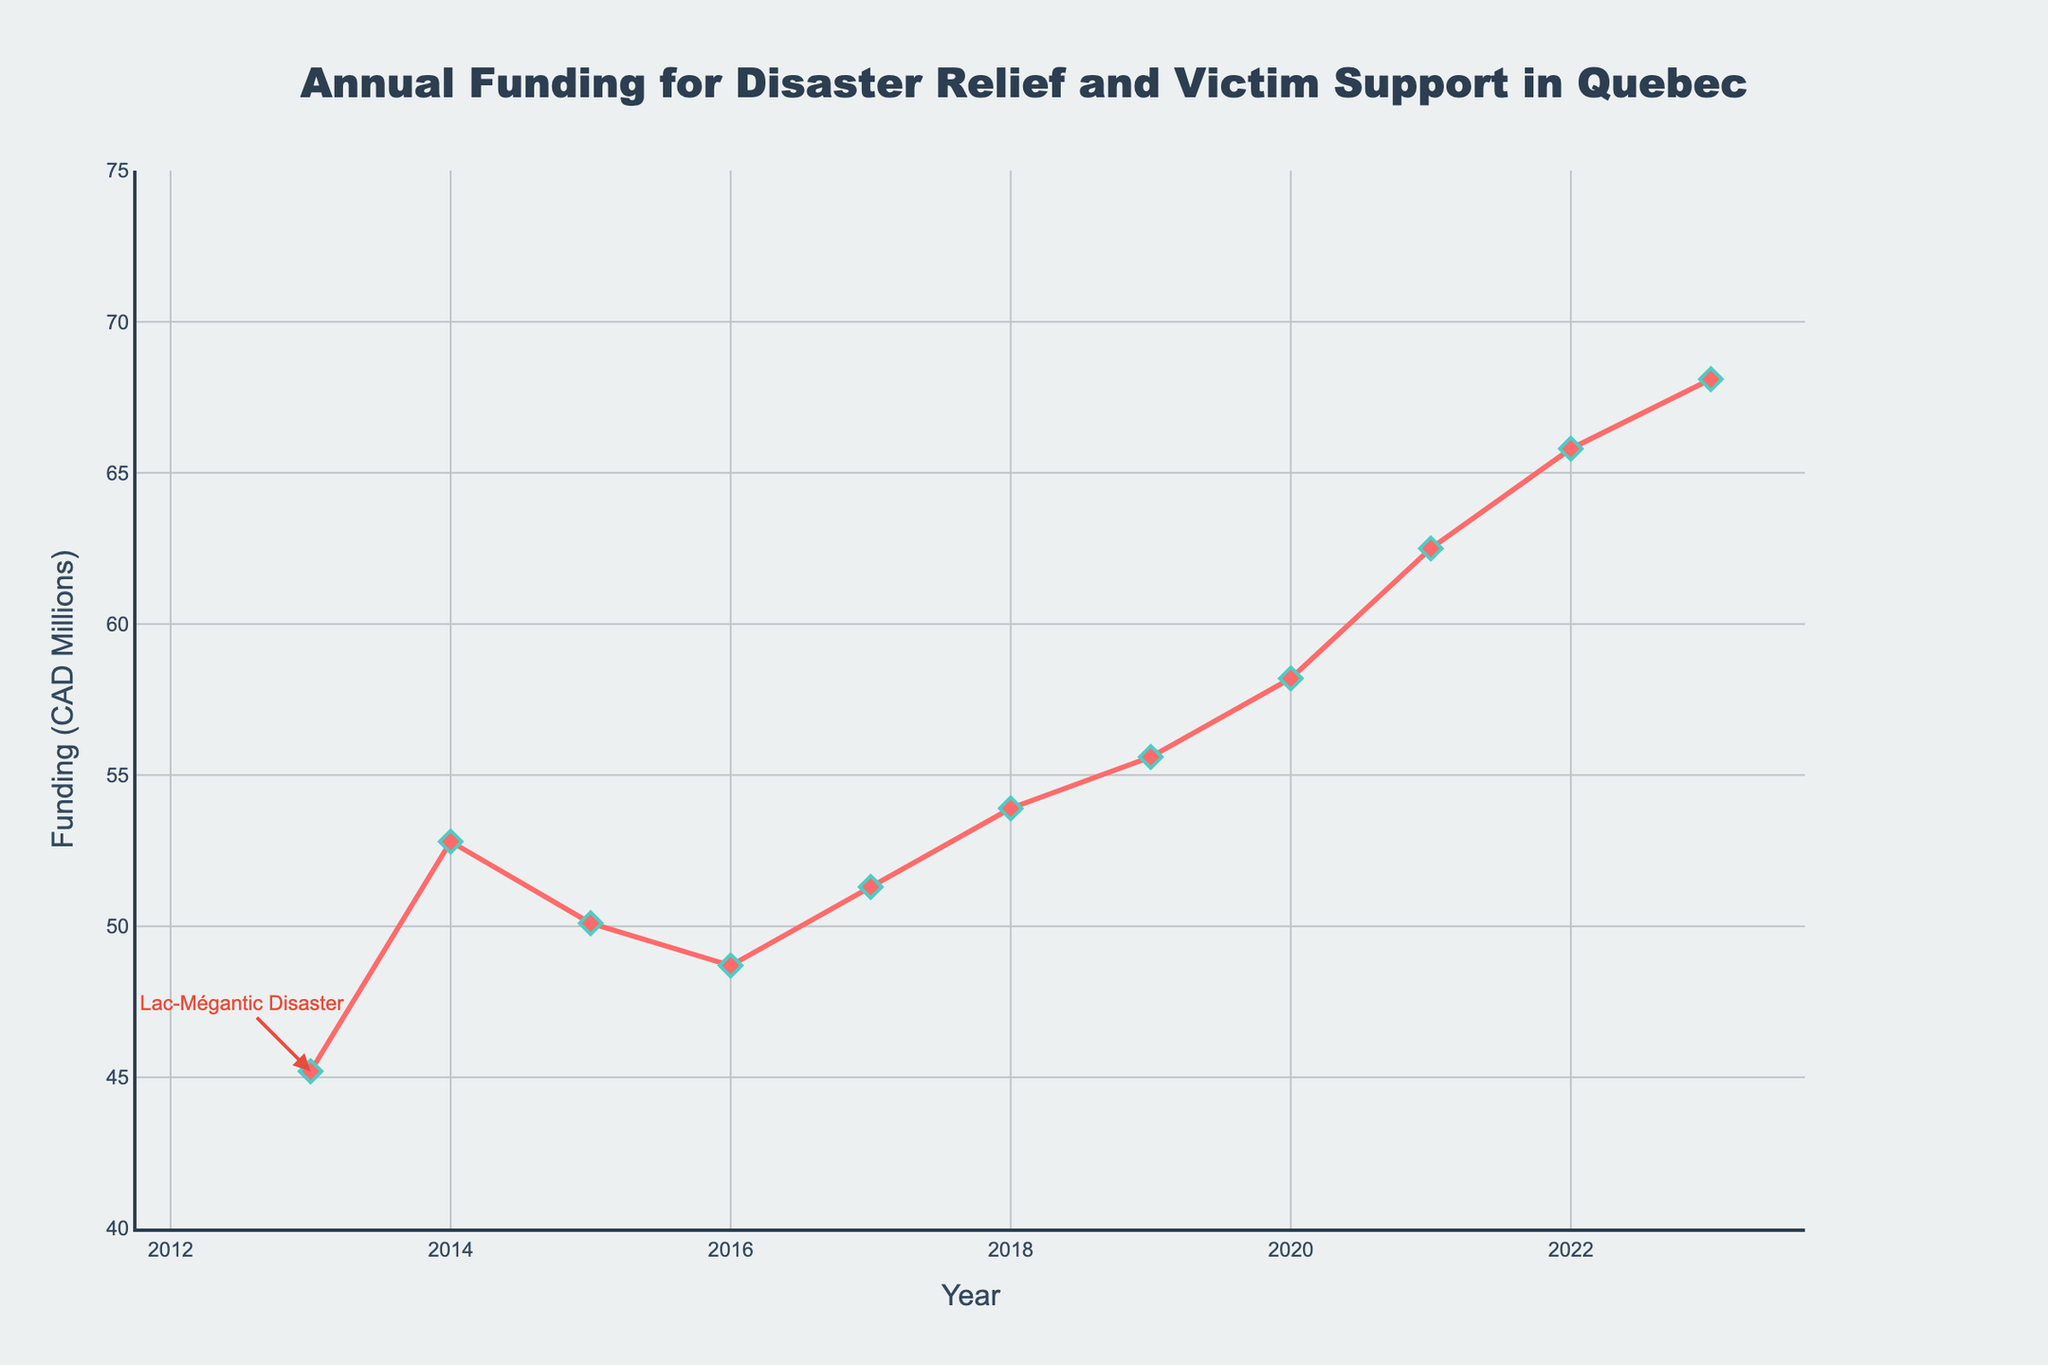What was the funding allocated in the year of the Lac-Mégantic disaster? The figure shows an annotation pointing to the year 2013 with a funding amount of 45.2 million CAD.
Answer: 45.2 million CAD How much did the funding increase from 2013 to 2014? According to the figure, the funding in 2013 was 45.2 million CAD and in 2014 it was 52.8 million CAD. The increase can be calculated as 52.8 - 45.2.
Answer: 7.6 million CAD Which year marked the highest funding allocation? The highest point on the line in the figure corresponds to the year 2023 with a value of 68.1 million CAD.
Answer: 2023 How much was the funding in 2018 compared to 2016? From the figure, the funding in 2016 was 48.7 million CAD and in 2018 it was 53.9 million CAD. To find the difference, we subtract 48.7 from 53.9.
Answer: 5.2 million CAD more What is the average annual funding from 2013 to 2023? First, sum up all annual funding values: 45.2 + 52.8 + 50.1 + 48.7 + 51.3 + 53.9 + 55.6 + 58.2 + 62.5 + 65.8 + 68.1 = 612.2 million CAD. Then, divide by the number of years, which is 11.
Answer: 55.7 million CAD Describe the trend in annual funding from 2013 to 2023. The line chart shows an overall upward trend with some fluctuations. Funding started at 45.2 million CAD in 2013 and gradually increased over the years, reaching 68.1 million CAD by 2023.
Answer: Upward trend In which years did the funding decrease compared to the previous year? By examining the line chart, it is clear that funding decreased from 2014 to 2015 (52.8 to 50.1 million CAD) and from 2015 to 2016 (50.1 to 48.7 million CAD).
Answer: 2015 and 2016 How does the 2020 funding compare to the 2013 funding? The funding in 2020 was 58.2 million CAD, while in 2013 it was 45.2 million CAD. The increase can be calculated as 58.2 - 45.2.
Answer: 13 million CAD more What is the percentage change in funding from 2019 to 2023? The funding in 2019 was 55.6 million CAD and in 2023 it was 68.1 million CAD. The percentage change is calculated as ((68.1 - 55.6) / 55.6) * 100.
Answer: 22.55% Explain the funding trend between 2017 to 2019. According to the figure, funding increased each year in this period: from 51.3 million CAD in 2017 to 53.9 in 2018, and 55.6 in 2019.
Answer: Gradual increase 